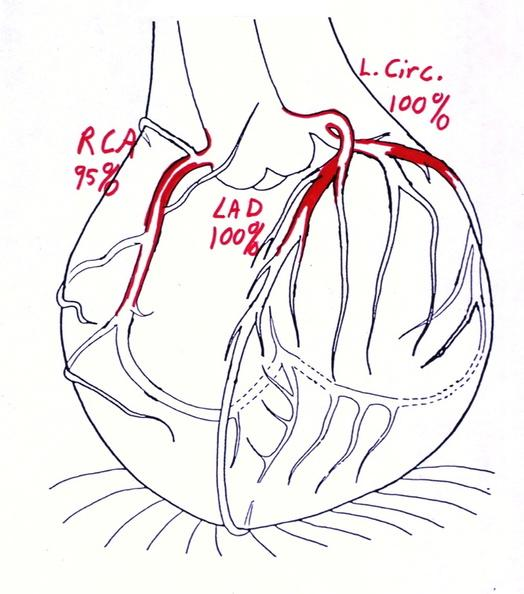does this image show coronary artery atherosclerosis diagram?
Answer the question using a single word or phrase. Yes 